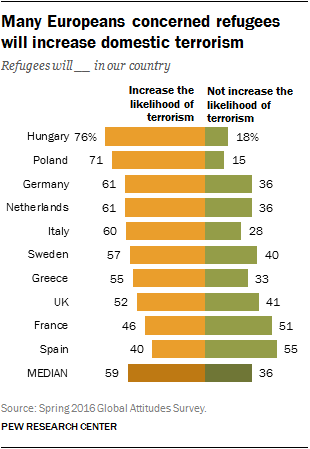Identify some key points in this picture. It is estimated that only two countries have fewer than 50% of their population concerned about the increasing likelihood of terrorism. A recent survey in the UK has revealed that 0.52% of people are thinking of increasing terrorism. 